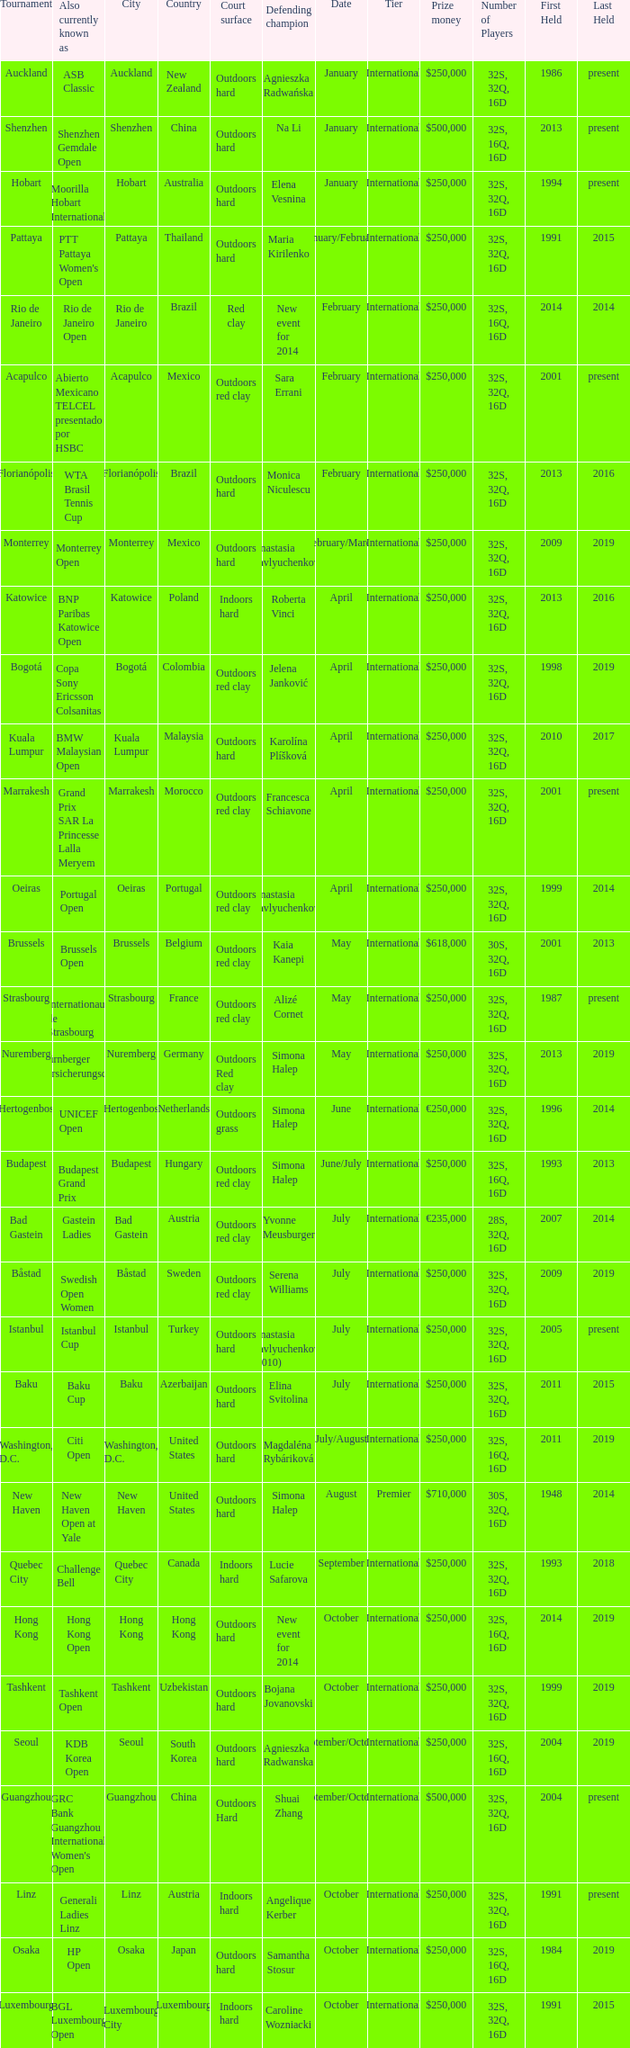What is the current number of tournaments referred to as the hp open? 1.0. Could you help me parse every detail presented in this table? {'header': ['Tournament', 'Also currently known as', 'City', 'Country', 'Court surface', 'Defending champion', 'Date', 'Tier', 'Prize money', 'Number of Players', 'First Held', 'Last Held'], 'rows': [['Auckland', 'ASB Classic', 'Auckland', 'New Zealand', 'Outdoors hard', 'Agnieszka Radwańska', 'January', 'International', '$250,000', '32S, 32Q, 16D', '1986', 'present'], ['Shenzhen', 'Shenzhen Gemdale Open', 'Shenzhen', 'China', 'Outdoors hard', 'Na Li', 'January', 'International', '$500,000', '32S, 16Q, 16D', '2013', 'present'], ['Hobart', 'Moorilla Hobart International', 'Hobart', 'Australia', 'Outdoors hard', 'Elena Vesnina', 'January', 'International', '$250,000', '32S, 32Q, 16D', '1994', 'present'], ['Pattaya', "PTT Pattaya Women's Open", 'Pattaya', 'Thailand', 'Outdoors hard', 'Maria Kirilenko', 'January/February', 'International', '$250,000', '32S, 32Q, 16D', '1991', '2015'], ['Rio de Janeiro', 'Rio de Janeiro Open', 'Rio de Janeiro', 'Brazil', 'Red clay', 'New event for 2014', 'February', 'International', '$250,000', '32S, 16Q, 16D', '2014', '2014'], ['Acapulco', 'Abierto Mexicano TELCEL presentado por HSBC', 'Acapulco', 'Mexico', 'Outdoors red clay', 'Sara Errani', 'February', 'International', '$250,000', '32S, 32Q, 16D', '2001', 'present'], ['Florianópolis', 'WTA Brasil Tennis Cup', 'Florianópolis', 'Brazil', 'Outdoors hard', 'Monica Niculescu', 'February', 'International', '$250,000', '32S, 32Q, 16D', '2013', '2016'], ['Monterrey', 'Monterrey Open', 'Monterrey', 'Mexico', 'Outdoors hard', 'Anastasia Pavlyuchenkova', 'February/March', 'International', '$250,000', '32S, 32Q, 16D', '2009', '2019'], ['Katowice', 'BNP Paribas Katowice Open', 'Katowice', 'Poland', 'Indoors hard', 'Roberta Vinci', 'April', 'International', '$250,000', '32S, 32Q, 16D', '2013', '2016'], ['Bogotá', 'Copa Sony Ericsson Colsanitas', 'Bogotá', 'Colombia', 'Outdoors red clay', 'Jelena Janković', 'April', 'International', '$250,000', '32S, 32Q, 16D', '1998', '2019'], ['Kuala Lumpur', 'BMW Malaysian Open', 'Kuala Lumpur', 'Malaysia', 'Outdoors hard', 'Karolína Plíšková', 'April', 'International', '$250,000', '32S, 32Q, 16D', '2010', '2017'], ['Marrakesh', 'Grand Prix SAR La Princesse Lalla Meryem', 'Marrakesh', 'Morocco', 'Outdoors red clay', 'Francesca Schiavone', 'April', 'International', '$250,000', '32S, 32Q, 16D', '2001', 'present'], ['Oeiras', 'Portugal Open', 'Oeiras', 'Portugal', 'Outdoors red clay', 'Anastasia Pavlyuchenkova', 'April', 'International', '$250,000', '32S, 32Q, 16D', '1999', '2014'], ['Brussels', 'Brussels Open', 'Brussels', 'Belgium', 'Outdoors red clay', 'Kaia Kanepi', 'May', 'International', '$618,000', '30S, 32Q, 16D', '2001', '2013'], ['Strasbourg', 'Internationaux de Strasbourg', 'Strasbourg', 'France', 'Outdoors red clay', 'Alizé Cornet', 'May', 'International', '$250,000', '32S, 32Q, 16D', '1987', 'present'], ['Nuremberg', 'Nürnberger Versicherungscup', 'Nuremberg', 'Germany', 'Outdoors Red clay', 'Simona Halep', 'May', 'International', '$250,000', '32S, 32Q, 16D', '2013', '2019'], ["'s-Hertogenbosch", 'UNICEF Open', "'s-Hertogenbosch", 'Netherlands', 'Outdoors grass', 'Simona Halep', 'June', 'International', '€250,000', '32S, 32Q, 16D', '1996', '2014'], ['Budapest', 'Budapest Grand Prix', 'Budapest', 'Hungary', 'Outdoors red clay', 'Simona Halep', 'June/July', 'International', '$250,000', '32S, 16Q, 16D', '1993', '2013'], ['Bad Gastein', 'Gastein Ladies', 'Bad Gastein', 'Austria', 'Outdoors red clay', 'Yvonne Meusburger', 'July', 'International', '€235,000', '28S, 32Q, 16D', '2007', '2014'], ['Båstad', 'Swedish Open Women', 'Båstad', 'Sweden', 'Outdoors red clay', 'Serena Williams', 'July', 'International', '$250,000', '32S, 32Q, 16D', '2009', '2019'], ['Istanbul', 'Istanbul Cup', 'Istanbul', 'Turkey', 'Outdoors hard', 'Anastasia Pavlyuchenkova (2010)', 'July', 'International', '$250,000', '32S, 32Q, 16D', '2005', 'present'], ['Baku', 'Baku Cup', 'Baku', 'Azerbaijan', 'Outdoors hard', 'Elina Svitolina', 'July', 'International', '$250,000', '32S, 32Q, 16D', '2011', '2015'], ['Washington, D.C.', 'Citi Open', 'Washington, D.C.', 'United States', 'Outdoors hard', 'Magdaléna Rybáriková', 'July/August', 'International', '$250,000', '32S, 16Q, 16D', '2011', '2019'], ['New Haven', 'New Haven Open at Yale', 'New Haven', 'United States', 'Outdoors hard', 'Simona Halep', 'August', 'Premier', '$710,000', '30S, 32Q, 16D', '1948', '2014'], ['Quebec City', 'Challenge Bell', 'Quebec City', 'Canada', 'Indoors hard', 'Lucie Safarova', 'September', 'International', '$250,000', '32S, 32Q, 16D', '1993', '2018'], ['Hong Kong', 'Hong Kong Open', 'Hong Kong', 'Hong Kong', 'Outdoors hard', 'New event for 2014', 'October', 'International', '$250,000', '32S, 16Q, 16D', '2014', '2019'], ['Tashkent', 'Tashkent Open', 'Tashkent', 'Uzbekistan', 'Outdoors hard', 'Bojana Jovanovski', 'October', 'International', '$250,000', '32S, 32Q, 16D', '1999', '2019'], ['Seoul', 'KDB Korea Open', 'Seoul', 'South Korea', 'Outdoors hard', 'Agnieszka Radwanska', 'September/October', 'International', '$250,000', '32S, 16Q, 16D', '2004', '2019'], ['Guangzhou', "GRC Bank Guangzhou International Women's Open", 'Guangzhou', 'China', 'Outdoors Hard', 'Shuai Zhang', 'September/October', 'International', '$500,000', '32S, 32Q, 16D', '2004', 'present'], ['Linz', 'Generali Ladies Linz', 'Linz', 'Austria', 'Indoors hard', 'Angelique Kerber', 'October', 'International', '$250,000', '32S, 32Q, 16D', '1991', 'present'], ['Osaka', 'HP Open', 'Osaka', 'Japan', 'Outdoors hard', 'Samantha Stosur', 'October', 'International', '$250,000', '32S, 16Q, 16D', '1984', '2019'], ['Luxembourg', 'BGL Luxembourg Open', 'Luxembourg City', 'Luxembourg', 'Indoors hard', 'Caroline Wozniacki', 'October', 'International', '$250,000', '32S, 32Q, 16D', '1991', '2015']]} 